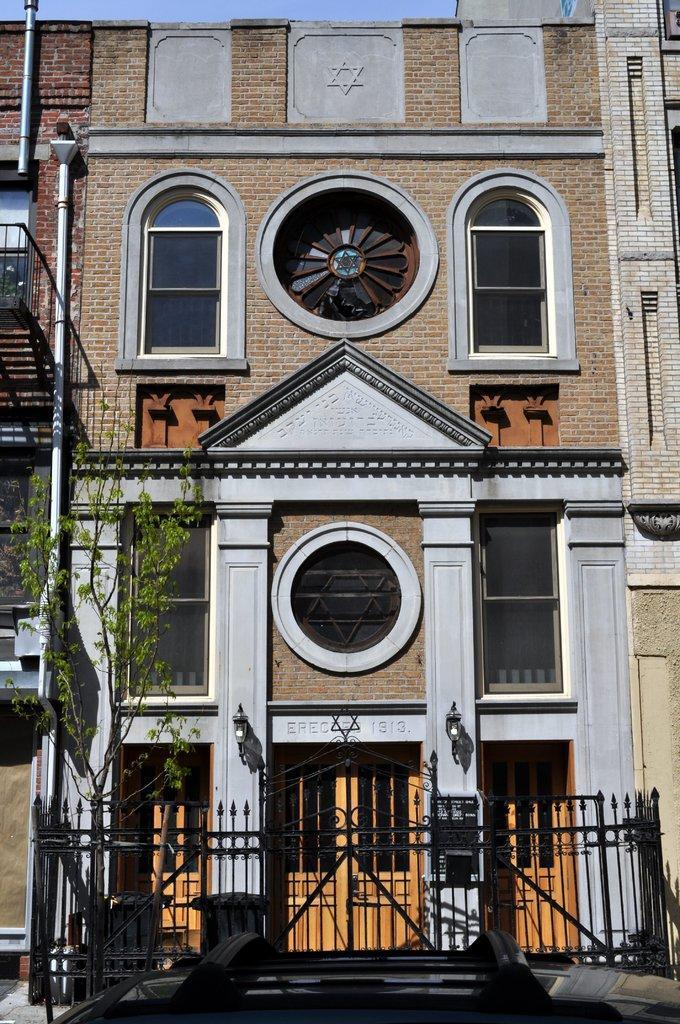Describe this image in one or two sentences. In this image I can see on the left side there is a tree. At the bottom there is an iron fencing, in the middle it is a very big building with glass windows. 